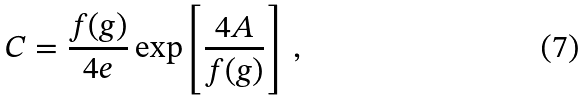Convert formula to latex. <formula><loc_0><loc_0><loc_500><loc_500>C = \frac { f ( g ) } { 4 e } \exp \left [ { \frac { 4 A } { f ( g ) } } \right ] \ ,</formula> 